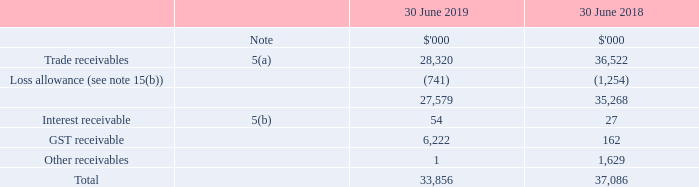Operating assets and liabilities
5 Trade and other receivables
(a) Trade receivables
(i) Classification as trade receivables
Trade receivables are amounts due from customers for goods sold or services performed in the ordinary course of business. They are generally due for settlement within 30 - 60 days and therefore are all classified as current. Trade receivables are recognised initially at the amount of consideration that is unconditional unless they contain significant financing components, when they are recognised at fair value. The Group holds the trade receivables with the objective to collect the contractual cash flows and therefore measures them subsequently at amortised cost using the effective interest method.
(ii) Fair values of trade and other receivables
Due to the short-term nature of the trade and other receivables, their carrying amount is considered to be the same as their fair value.
(iii) Impairment and risk exposure
Information about the Group's impairment policies, calculation of loss allowance and exposure to credit risk, foreign currency risk and interest rate risk can be found in note 15.
(b) Interest receivable
Interest receivable relates to interest accrued on term deposits. Credit risk of this is assessed in the same manner as cash and cash equivalents which is detailed in note 15.
What was the GST receivable for 2019 and 2018 respectively?
Answer scale should be: thousand. 6,222, 162. Why was trade receivables considered under current assets? Generally due for settlement within 30 - 60 days and therefore are all classified as current. How much was the net trade receivables for 2018?
Answer scale should be: thousand. 35,268. What was the percentage change in trade receivables between 2018 and 2019?
Answer scale should be: percent. (28,320 - 36,522) / 36,522 
Answer: -22.46. What was the percentage change in GST receivables between 2018 and 2019?
Answer scale should be: percent. (6,222 - 162) / 162 
Answer: 3740.74. What was the difference between trade and GST receivables in 2018?
Answer scale should be: thousand. 36,522 - 162 
Answer: 36360. 